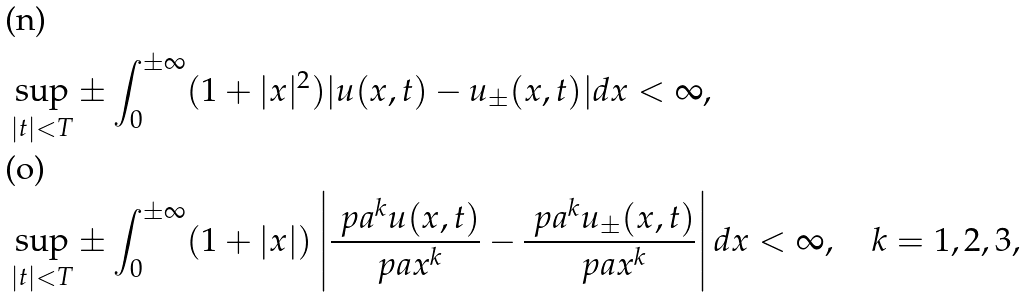Convert formula to latex. <formula><loc_0><loc_0><loc_500><loc_500>& \sup _ { | t | < T } \pm \int _ { 0 } ^ { \pm \infty } ( 1 + | x | ^ { 2 } ) | u ( x , t ) - u _ { \pm } ( x , t ) | d x < \infty , \\ & \sup _ { | t | < T } \pm \int _ { 0 } ^ { \pm \infty } ( 1 + | x | ) \left | \frac { \ p a ^ { k } u ( x , t ) } { \ p a x ^ { k } } - \frac { \ p a ^ { k } u _ { \pm } ( x , t ) } { \ p a x ^ { k } } \right | d x < \infty , \quad k = 1 , 2 , 3 ,</formula> 